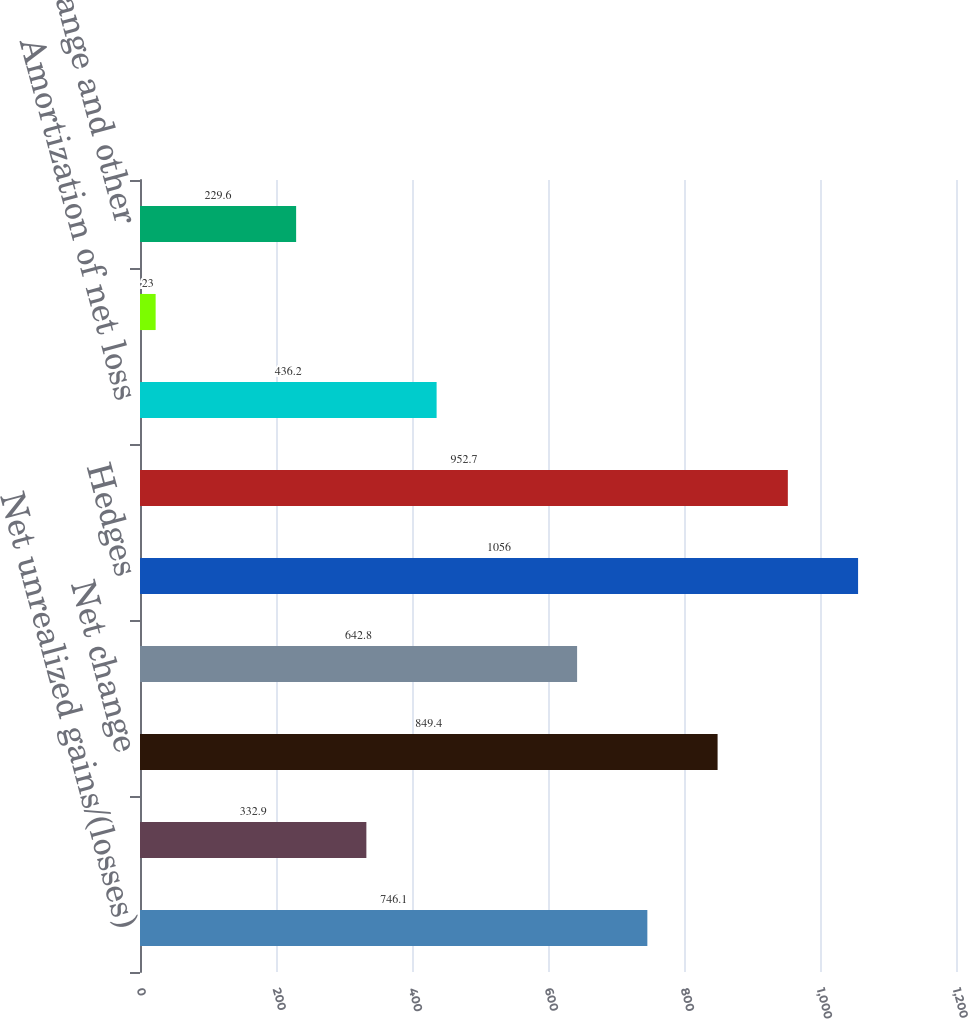Convert chart to OTSL. <chart><loc_0><loc_0><loc_500><loc_500><bar_chart><fcel>Net unrealized gains/(losses)<fcel>Reclassification adjustment<fcel>Net change<fcel>Translation<fcel>Hedges<fcel>Net gain/(loss) arising during<fcel>Amortization of net loss<fcel>Amortization of prior service<fcel>Foreign exchange and other<nl><fcel>746.1<fcel>332.9<fcel>849.4<fcel>642.8<fcel>1056<fcel>952.7<fcel>436.2<fcel>23<fcel>229.6<nl></chart> 